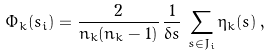Convert formula to latex. <formula><loc_0><loc_0><loc_500><loc_500>\Phi _ { k } ( s _ { i } ) = \frac { 2 } { n _ { k } ( n _ { k } - 1 ) } \, \frac { 1 } { \delta s } \, \sum _ { s \in J _ { i } } \eta _ { k } ( s ) \, ,</formula> 